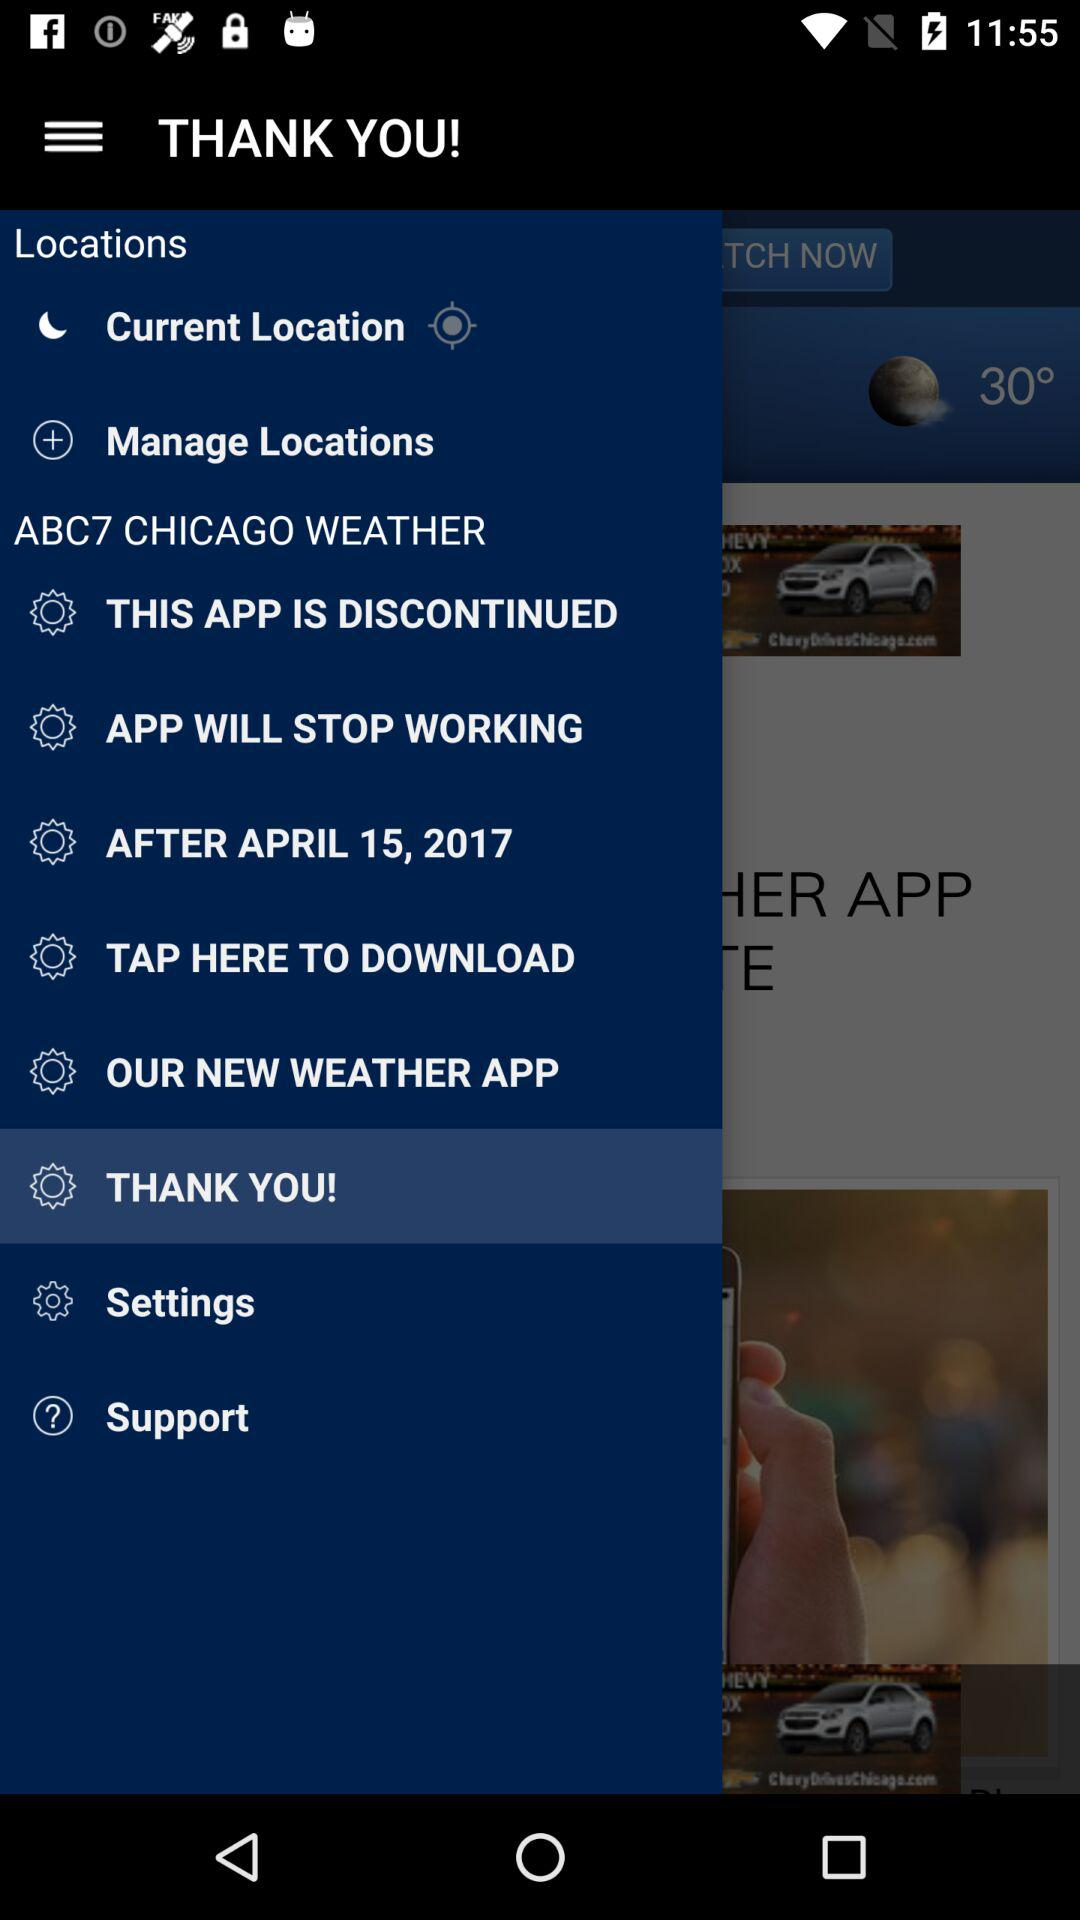After which date will the application stop working?
When the provided information is insufficient, respond with <no answer>. <no answer> 